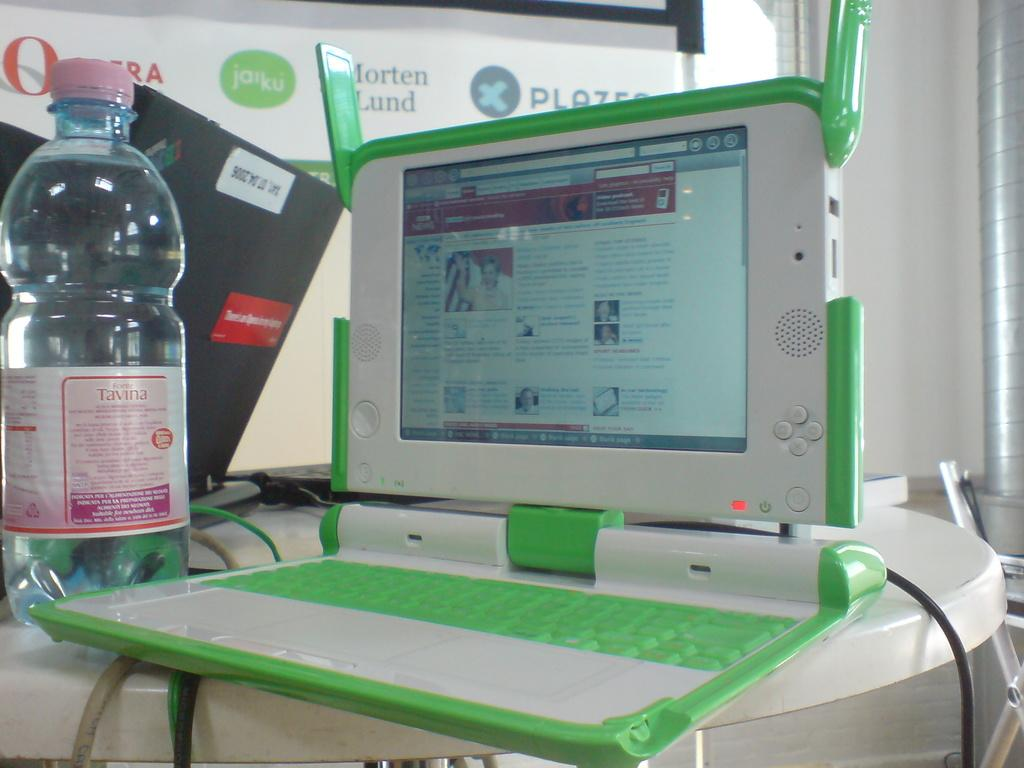<image>
Summarize the visual content of the image. A table with an open laptop and a bottle of Tavina. 